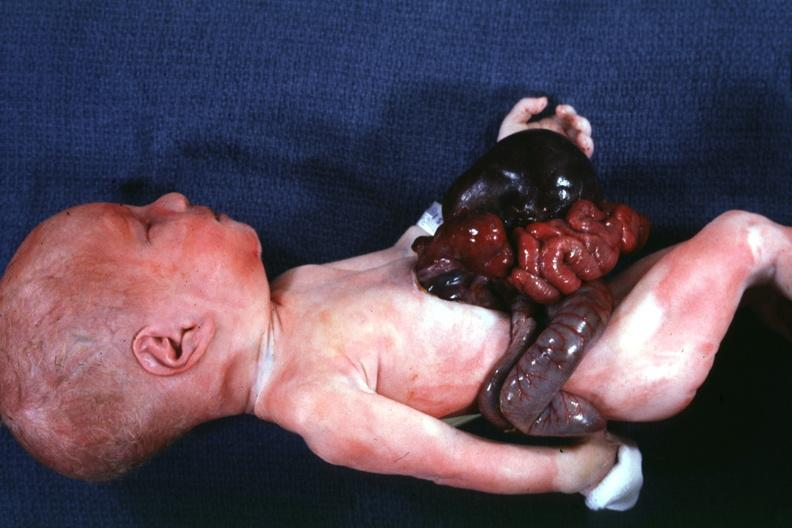s abdomen present?
Answer the question using a single word or phrase. Yes 